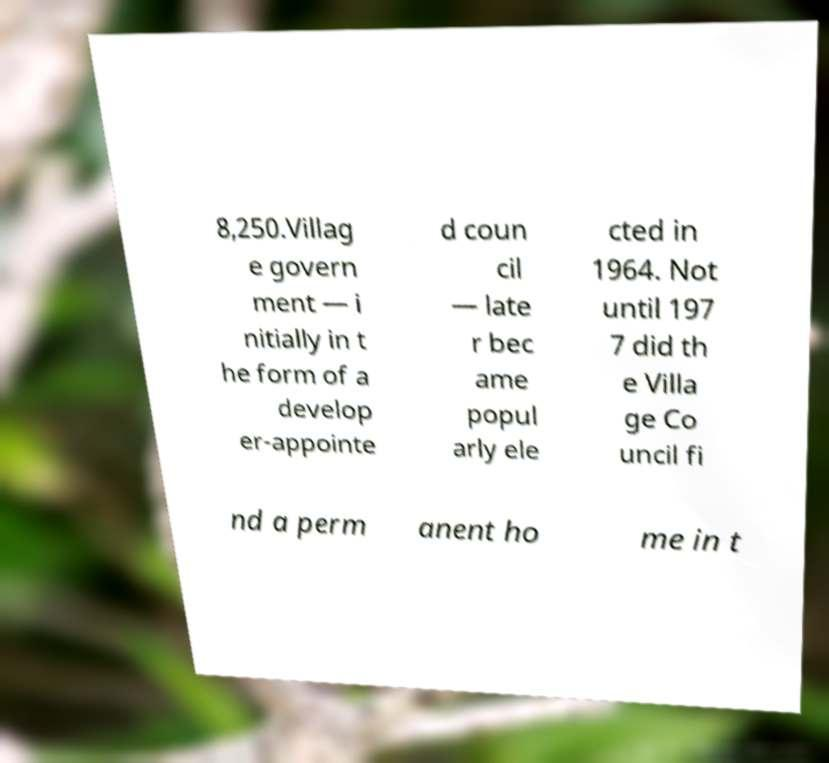I need the written content from this picture converted into text. Can you do that? 8,250.Villag e govern ment — i nitially in t he form of a develop er-appointe d coun cil — late r bec ame popul arly ele cted in 1964. Not until 197 7 did th e Villa ge Co uncil fi nd a perm anent ho me in t 